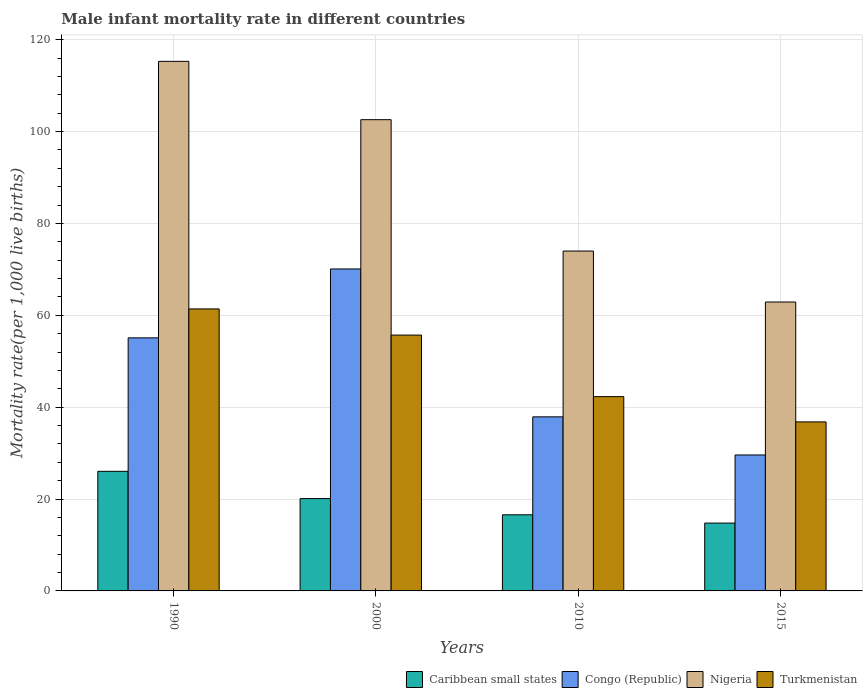Are the number of bars per tick equal to the number of legend labels?
Offer a terse response. Yes. Are the number of bars on each tick of the X-axis equal?
Offer a very short reply. Yes. How many bars are there on the 3rd tick from the left?
Provide a short and direct response. 4. What is the male infant mortality rate in Congo (Republic) in 2010?
Ensure brevity in your answer.  37.9. Across all years, what is the maximum male infant mortality rate in Nigeria?
Offer a terse response. 115.3. Across all years, what is the minimum male infant mortality rate in Turkmenistan?
Your answer should be compact. 36.8. In which year was the male infant mortality rate in Congo (Republic) minimum?
Your answer should be very brief. 2015. What is the total male infant mortality rate in Nigeria in the graph?
Offer a very short reply. 354.8. What is the difference between the male infant mortality rate in Turkmenistan in 2000 and that in 2015?
Your response must be concise. 18.9. What is the difference between the male infant mortality rate in Nigeria in 2000 and the male infant mortality rate in Turkmenistan in 2015?
Give a very brief answer. 65.8. What is the average male infant mortality rate in Congo (Republic) per year?
Your answer should be compact. 48.17. In the year 2010, what is the difference between the male infant mortality rate in Nigeria and male infant mortality rate in Turkmenistan?
Ensure brevity in your answer.  31.7. What is the ratio of the male infant mortality rate in Caribbean small states in 2000 to that in 2010?
Make the answer very short. 1.21. Is the male infant mortality rate in Congo (Republic) in 2000 less than that in 2015?
Provide a succinct answer. No. Is the difference between the male infant mortality rate in Nigeria in 1990 and 2010 greater than the difference between the male infant mortality rate in Turkmenistan in 1990 and 2010?
Your answer should be compact. Yes. What is the difference between the highest and the second highest male infant mortality rate in Nigeria?
Ensure brevity in your answer.  12.7. What is the difference between the highest and the lowest male infant mortality rate in Nigeria?
Your response must be concise. 52.4. In how many years, is the male infant mortality rate in Turkmenistan greater than the average male infant mortality rate in Turkmenistan taken over all years?
Offer a very short reply. 2. Is it the case that in every year, the sum of the male infant mortality rate in Caribbean small states and male infant mortality rate in Congo (Republic) is greater than the sum of male infant mortality rate in Turkmenistan and male infant mortality rate in Nigeria?
Provide a succinct answer. No. What does the 4th bar from the left in 2010 represents?
Offer a terse response. Turkmenistan. What does the 4th bar from the right in 1990 represents?
Offer a terse response. Caribbean small states. Is it the case that in every year, the sum of the male infant mortality rate in Congo (Republic) and male infant mortality rate in Caribbean small states is greater than the male infant mortality rate in Turkmenistan?
Offer a terse response. Yes. What is the difference between two consecutive major ticks on the Y-axis?
Make the answer very short. 20. Does the graph contain any zero values?
Provide a short and direct response. No. How many legend labels are there?
Give a very brief answer. 4. What is the title of the graph?
Offer a very short reply. Male infant mortality rate in different countries. What is the label or title of the Y-axis?
Offer a terse response. Mortality rate(per 1,0 live births). What is the Mortality rate(per 1,000 live births) of Caribbean small states in 1990?
Offer a very short reply. 26.04. What is the Mortality rate(per 1,000 live births) of Congo (Republic) in 1990?
Provide a succinct answer. 55.1. What is the Mortality rate(per 1,000 live births) of Nigeria in 1990?
Provide a short and direct response. 115.3. What is the Mortality rate(per 1,000 live births) of Turkmenistan in 1990?
Make the answer very short. 61.4. What is the Mortality rate(per 1,000 live births) in Caribbean small states in 2000?
Ensure brevity in your answer.  20.1. What is the Mortality rate(per 1,000 live births) in Congo (Republic) in 2000?
Offer a very short reply. 70.1. What is the Mortality rate(per 1,000 live births) of Nigeria in 2000?
Offer a very short reply. 102.6. What is the Mortality rate(per 1,000 live births) in Turkmenistan in 2000?
Offer a very short reply. 55.7. What is the Mortality rate(per 1,000 live births) of Caribbean small states in 2010?
Offer a very short reply. 16.57. What is the Mortality rate(per 1,000 live births) in Congo (Republic) in 2010?
Provide a short and direct response. 37.9. What is the Mortality rate(per 1,000 live births) in Turkmenistan in 2010?
Your answer should be compact. 42.3. What is the Mortality rate(per 1,000 live births) in Caribbean small states in 2015?
Your answer should be very brief. 14.77. What is the Mortality rate(per 1,000 live births) in Congo (Republic) in 2015?
Ensure brevity in your answer.  29.6. What is the Mortality rate(per 1,000 live births) in Nigeria in 2015?
Provide a succinct answer. 62.9. What is the Mortality rate(per 1,000 live births) in Turkmenistan in 2015?
Provide a succinct answer. 36.8. Across all years, what is the maximum Mortality rate(per 1,000 live births) of Caribbean small states?
Offer a very short reply. 26.04. Across all years, what is the maximum Mortality rate(per 1,000 live births) of Congo (Republic)?
Your answer should be compact. 70.1. Across all years, what is the maximum Mortality rate(per 1,000 live births) in Nigeria?
Offer a very short reply. 115.3. Across all years, what is the maximum Mortality rate(per 1,000 live births) of Turkmenistan?
Your answer should be very brief. 61.4. Across all years, what is the minimum Mortality rate(per 1,000 live births) in Caribbean small states?
Offer a very short reply. 14.77. Across all years, what is the minimum Mortality rate(per 1,000 live births) of Congo (Republic)?
Your response must be concise. 29.6. Across all years, what is the minimum Mortality rate(per 1,000 live births) in Nigeria?
Your answer should be compact. 62.9. Across all years, what is the minimum Mortality rate(per 1,000 live births) in Turkmenistan?
Provide a succinct answer. 36.8. What is the total Mortality rate(per 1,000 live births) in Caribbean small states in the graph?
Your answer should be very brief. 77.48. What is the total Mortality rate(per 1,000 live births) in Congo (Republic) in the graph?
Your response must be concise. 192.7. What is the total Mortality rate(per 1,000 live births) of Nigeria in the graph?
Make the answer very short. 354.8. What is the total Mortality rate(per 1,000 live births) of Turkmenistan in the graph?
Offer a very short reply. 196.2. What is the difference between the Mortality rate(per 1,000 live births) of Caribbean small states in 1990 and that in 2000?
Ensure brevity in your answer.  5.94. What is the difference between the Mortality rate(per 1,000 live births) of Congo (Republic) in 1990 and that in 2000?
Offer a terse response. -15. What is the difference between the Mortality rate(per 1,000 live births) of Nigeria in 1990 and that in 2000?
Your response must be concise. 12.7. What is the difference between the Mortality rate(per 1,000 live births) of Caribbean small states in 1990 and that in 2010?
Ensure brevity in your answer.  9.47. What is the difference between the Mortality rate(per 1,000 live births) in Nigeria in 1990 and that in 2010?
Ensure brevity in your answer.  41.3. What is the difference between the Mortality rate(per 1,000 live births) in Turkmenistan in 1990 and that in 2010?
Offer a very short reply. 19.1. What is the difference between the Mortality rate(per 1,000 live births) of Caribbean small states in 1990 and that in 2015?
Ensure brevity in your answer.  11.27. What is the difference between the Mortality rate(per 1,000 live births) of Nigeria in 1990 and that in 2015?
Provide a succinct answer. 52.4. What is the difference between the Mortality rate(per 1,000 live births) in Turkmenistan in 1990 and that in 2015?
Make the answer very short. 24.6. What is the difference between the Mortality rate(per 1,000 live births) in Caribbean small states in 2000 and that in 2010?
Offer a very short reply. 3.53. What is the difference between the Mortality rate(per 1,000 live births) of Congo (Republic) in 2000 and that in 2010?
Your answer should be very brief. 32.2. What is the difference between the Mortality rate(per 1,000 live births) in Nigeria in 2000 and that in 2010?
Your answer should be compact. 28.6. What is the difference between the Mortality rate(per 1,000 live births) of Caribbean small states in 2000 and that in 2015?
Keep it short and to the point. 5.33. What is the difference between the Mortality rate(per 1,000 live births) of Congo (Republic) in 2000 and that in 2015?
Your answer should be compact. 40.5. What is the difference between the Mortality rate(per 1,000 live births) of Nigeria in 2000 and that in 2015?
Your response must be concise. 39.7. What is the difference between the Mortality rate(per 1,000 live births) in Turkmenistan in 2000 and that in 2015?
Your response must be concise. 18.9. What is the difference between the Mortality rate(per 1,000 live births) in Caribbean small states in 2010 and that in 2015?
Offer a terse response. 1.8. What is the difference between the Mortality rate(per 1,000 live births) of Congo (Republic) in 2010 and that in 2015?
Give a very brief answer. 8.3. What is the difference between the Mortality rate(per 1,000 live births) in Nigeria in 2010 and that in 2015?
Provide a succinct answer. 11.1. What is the difference between the Mortality rate(per 1,000 live births) in Caribbean small states in 1990 and the Mortality rate(per 1,000 live births) in Congo (Republic) in 2000?
Offer a very short reply. -44.06. What is the difference between the Mortality rate(per 1,000 live births) in Caribbean small states in 1990 and the Mortality rate(per 1,000 live births) in Nigeria in 2000?
Ensure brevity in your answer.  -76.56. What is the difference between the Mortality rate(per 1,000 live births) of Caribbean small states in 1990 and the Mortality rate(per 1,000 live births) of Turkmenistan in 2000?
Your answer should be very brief. -29.66. What is the difference between the Mortality rate(per 1,000 live births) of Congo (Republic) in 1990 and the Mortality rate(per 1,000 live births) of Nigeria in 2000?
Your response must be concise. -47.5. What is the difference between the Mortality rate(per 1,000 live births) in Congo (Republic) in 1990 and the Mortality rate(per 1,000 live births) in Turkmenistan in 2000?
Give a very brief answer. -0.6. What is the difference between the Mortality rate(per 1,000 live births) in Nigeria in 1990 and the Mortality rate(per 1,000 live births) in Turkmenistan in 2000?
Ensure brevity in your answer.  59.6. What is the difference between the Mortality rate(per 1,000 live births) in Caribbean small states in 1990 and the Mortality rate(per 1,000 live births) in Congo (Republic) in 2010?
Offer a terse response. -11.86. What is the difference between the Mortality rate(per 1,000 live births) of Caribbean small states in 1990 and the Mortality rate(per 1,000 live births) of Nigeria in 2010?
Your answer should be compact. -47.96. What is the difference between the Mortality rate(per 1,000 live births) of Caribbean small states in 1990 and the Mortality rate(per 1,000 live births) of Turkmenistan in 2010?
Provide a succinct answer. -16.26. What is the difference between the Mortality rate(per 1,000 live births) of Congo (Republic) in 1990 and the Mortality rate(per 1,000 live births) of Nigeria in 2010?
Your response must be concise. -18.9. What is the difference between the Mortality rate(per 1,000 live births) of Congo (Republic) in 1990 and the Mortality rate(per 1,000 live births) of Turkmenistan in 2010?
Keep it short and to the point. 12.8. What is the difference between the Mortality rate(per 1,000 live births) of Caribbean small states in 1990 and the Mortality rate(per 1,000 live births) of Congo (Republic) in 2015?
Make the answer very short. -3.56. What is the difference between the Mortality rate(per 1,000 live births) of Caribbean small states in 1990 and the Mortality rate(per 1,000 live births) of Nigeria in 2015?
Your answer should be compact. -36.86. What is the difference between the Mortality rate(per 1,000 live births) in Caribbean small states in 1990 and the Mortality rate(per 1,000 live births) in Turkmenistan in 2015?
Your answer should be compact. -10.76. What is the difference between the Mortality rate(per 1,000 live births) in Nigeria in 1990 and the Mortality rate(per 1,000 live births) in Turkmenistan in 2015?
Your response must be concise. 78.5. What is the difference between the Mortality rate(per 1,000 live births) in Caribbean small states in 2000 and the Mortality rate(per 1,000 live births) in Congo (Republic) in 2010?
Your answer should be compact. -17.8. What is the difference between the Mortality rate(per 1,000 live births) in Caribbean small states in 2000 and the Mortality rate(per 1,000 live births) in Nigeria in 2010?
Provide a succinct answer. -53.9. What is the difference between the Mortality rate(per 1,000 live births) of Caribbean small states in 2000 and the Mortality rate(per 1,000 live births) of Turkmenistan in 2010?
Your response must be concise. -22.2. What is the difference between the Mortality rate(per 1,000 live births) in Congo (Republic) in 2000 and the Mortality rate(per 1,000 live births) in Nigeria in 2010?
Offer a terse response. -3.9. What is the difference between the Mortality rate(per 1,000 live births) in Congo (Republic) in 2000 and the Mortality rate(per 1,000 live births) in Turkmenistan in 2010?
Give a very brief answer. 27.8. What is the difference between the Mortality rate(per 1,000 live births) of Nigeria in 2000 and the Mortality rate(per 1,000 live births) of Turkmenistan in 2010?
Keep it short and to the point. 60.3. What is the difference between the Mortality rate(per 1,000 live births) in Caribbean small states in 2000 and the Mortality rate(per 1,000 live births) in Congo (Republic) in 2015?
Keep it short and to the point. -9.5. What is the difference between the Mortality rate(per 1,000 live births) of Caribbean small states in 2000 and the Mortality rate(per 1,000 live births) of Nigeria in 2015?
Make the answer very short. -42.8. What is the difference between the Mortality rate(per 1,000 live births) of Caribbean small states in 2000 and the Mortality rate(per 1,000 live births) of Turkmenistan in 2015?
Offer a terse response. -16.7. What is the difference between the Mortality rate(per 1,000 live births) of Congo (Republic) in 2000 and the Mortality rate(per 1,000 live births) of Turkmenistan in 2015?
Offer a very short reply. 33.3. What is the difference between the Mortality rate(per 1,000 live births) in Nigeria in 2000 and the Mortality rate(per 1,000 live births) in Turkmenistan in 2015?
Your answer should be very brief. 65.8. What is the difference between the Mortality rate(per 1,000 live births) of Caribbean small states in 2010 and the Mortality rate(per 1,000 live births) of Congo (Republic) in 2015?
Your answer should be compact. -13.03. What is the difference between the Mortality rate(per 1,000 live births) of Caribbean small states in 2010 and the Mortality rate(per 1,000 live births) of Nigeria in 2015?
Provide a succinct answer. -46.33. What is the difference between the Mortality rate(per 1,000 live births) of Caribbean small states in 2010 and the Mortality rate(per 1,000 live births) of Turkmenistan in 2015?
Keep it short and to the point. -20.23. What is the difference between the Mortality rate(per 1,000 live births) of Congo (Republic) in 2010 and the Mortality rate(per 1,000 live births) of Nigeria in 2015?
Your response must be concise. -25. What is the difference between the Mortality rate(per 1,000 live births) of Congo (Republic) in 2010 and the Mortality rate(per 1,000 live births) of Turkmenistan in 2015?
Make the answer very short. 1.1. What is the difference between the Mortality rate(per 1,000 live births) of Nigeria in 2010 and the Mortality rate(per 1,000 live births) of Turkmenistan in 2015?
Your answer should be very brief. 37.2. What is the average Mortality rate(per 1,000 live births) of Caribbean small states per year?
Provide a short and direct response. 19.37. What is the average Mortality rate(per 1,000 live births) of Congo (Republic) per year?
Ensure brevity in your answer.  48.17. What is the average Mortality rate(per 1,000 live births) in Nigeria per year?
Your response must be concise. 88.7. What is the average Mortality rate(per 1,000 live births) of Turkmenistan per year?
Provide a short and direct response. 49.05. In the year 1990, what is the difference between the Mortality rate(per 1,000 live births) of Caribbean small states and Mortality rate(per 1,000 live births) of Congo (Republic)?
Give a very brief answer. -29.06. In the year 1990, what is the difference between the Mortality rate(per 1,000 live births) in Caribbean small states and Mortality rate(per 1,000 live births) in Nigeria?
Offer a very short reply. -89.26. In the year 1990, what is the difference between the Mortality rate(per 1,000 live births) in Caribbean small states and Mortality rate(per 1,000 live births) in Turkmenistan?
Provide a short and direct response. -35.36. In the year 1990, what is the difference between the Mortality rate(per 1,000 live births) of Congo (Republic) and Mortality rate(per 1,000 live births) of Nigeria?
Offer a very short reply. -60.2. In the year 1990, what is the difference between the Mortality rate(per 1,000 live births) of Congo (Republic) and Mortality rate(per 1,000 live births) of Turkmenistan?
Your answer should be compact. -6.3. In the year 1990, what is the difference between the Mortality rate(per 1,000 live births) in Nigeria and Mortality rate(per 1,000 live births) in Turkmenistan?
Offer a terse response. 53.9. In the year 2000, what is the difference between the Mortality rate(per 1,000 live births) in Caribbean small states and Mortality rate(per 1,000 live births) in Congo (Republic)?
Give a very brief answer. -50. In the year 2000, what is the difference between the Mortality rate(per 1,000 live births) in Caribbean small states and Mortality rate(per 1,000 live births) in Nigeria?
Provide a short and direct response. -82.5. In the year 2000, what is the difference between the Mortality rate(per 1,000 live births) in Caribbean small states and Mortality rate(per 1,000 live births) in Turkmenistan?
Make the answer very short. -35.6. In the year 2000, what is the difference between the Mortality rate(per 1,000 live births) of Congo (Republic) and Mortality rate(per 1,000 live births) of Nigeria?
Make the answer very short. -32.5. In the year 2000, what is the difference between the Mortality rate(per 1,000 live births) of Congo (Republic) and Mortality rate(per 1,000 live births) of Turkmenistan?
Offer a very short reply. 14.4. In the year 2000, what is the difference between the Mortality rate(per 1,000 live births) in Nigeria and Mortality rate(per 1,000 live births) in Turkmenistan?
Your response must be concise. 46.9. In the year 2010, what is the difference between the Mortality rate(per 1,000 live births) in Caribbean small states and Mortality rate(per 1,000 live births) in Congo (Republic)?
Your answer should be compact. -21.33. In the year 2010, what is the difference between the Mortality rate(per 1,000 live births) in Caribbean small states and Mortality rate(per 1,000 live births) in Nigeria?
Your answer should be very brief. -57.43. In the year 2010, what is the difference between the Mortality rate(per 1,000 live births) of Caribbean small states and Mortality rate(per 1,000 live births) of Turkmenistan?
Make the answer very short. -25.73. In the year 2010, what is the difference between the Mortality rate(per 1,000 live births) in Congo (Republic) and Mortality rate(per 1,000 live births) in Nigeria?
Your response must be concise. -36.1. In the year 2010, what is the difference between the Mortality rate(per 1,000 live births) of Nigeria and Mortality rate(per 1,000 live births) of Turkmenistan?
Make the answer very short. 31.7. In the year 2015, what is the difference between the Mortality rate(per 1,000 live births) in Caribbean small states and Mortality rate(per 1,000 live births) in Congo (Republic)?
Provide a short and direct response. -14.83. In the year 2015, what is the difference between the Mortality rate(per 1,000 live births) in Caribbean small states and Mortality rate(per 1,000 live births) in Nigeria?
Provide a short and direct response. -48.13. In the year 2015, what is the difference between the Mortality rate(per 1,000 live births) of Caribbean small states and Mortality rate(per 1,000 live births) of Turkmenistan?
Provide a short and direct response. -22.03. In the year 2015, what is the difference between the Mortality rate(per 1,000 live births) of Congo (Republic) and Mortality rate(per 1,000 live births) of Nigeria?
Provide a succinct answer. -33.3. In the year 2015, what is the difference between the Mortality rate(per 1,000 live births) of Nigeria and Mortality rate(per 1,000 live births) of Turkmenistan?
Offer a terse response. 26.1. What is the ratio of the Mortality rate(per 1,000 live births) of Caribbean small states in 1990 to that in 2000?
Your answer should be compact. 1.3. What is the ratio of the Mortality rate(per 1,000 live births) of Congo (Republic) in 1990 to that in 2000?
Make the answer very short. 0.79. What is the ratio of the Mortality rate(per 1,000 live births) of Nigeria in 1990 to that in 2000?
Your answer should be compact. 1.12. What is the ratio of the Mortality rate(per 1,000 live births) of Turkmenistan in 1990 to that in 2000?
Your response must be concise. 1.1. What is the ratio of the Mortality rate(per 1,000 live births) in Caribbean small states in 1990 to that in 2010?
Provide a succinct answer. 1.57. What is the ratio of the Mortality rate(per 1,000 live births) of Congo (Republic) in 1990 to that in 2010?
Provide a short and direct response. 1.45. What is the ratio of the Mortality rate(per 1,000 live births) of Nigeria in 1990 to that in 2010?
Give a very brief answer. 1.56. What is the ratio of the Mortality rate(per 1,000 live births) in Turkmenistan in 1990 to that in 2010?
Make the answer very short. 1.45. What is the ratio of the Mortality rate(per 1,000 live births) in Caribbean small states in 1990 to that in 2015?
Keep it short and to the point. 1.76. What is the ratio of the Mortality rate(per 1,000 live births) in Congo (Republic) in 1990 to that in 2015?
Provide a short and direct response. 1.86. What is the ratio of the Mortality rate(per 1,000 live births) in Nigeria in 1990 to that in 2015?
Keep it short and to the point. 1.83. What is the ratio of the Mortality rate(per 1,000 live births) in Turkmenistan in 1990 to that in 2015?
Provide a short and direct response. 1.67. What is the ratio of the Mortality rate(per 1,000 live births) of Caribbean small states in 2000 to that in 2010?
Your answer should be compact. 1.21. What is the ratio of the Mortality rate(per 1,000 live births) of Congo (Republic) in 2000 to that in 2010?
Your answer should be compact. 1.85. What is the ratio of the Mortality rate(per 1,000 live births) in Nigeria in 2000 to that in 2010?
Offer a very short reply. 1.39. What is the ratio of the Mortality rate(per 1,000 live births) of Turkmenistan in 2000 to that in 2010?
Provide a succinct answer. 1.32. What is the ratio of the Mortality rate(per 1,000 live births) in Caribbean small states in 2000 to that in 2015?
Provide a short and direct response. 1.36. What is the ratio of the Mortality rate(per 1,000 live births) of Congo (Republic) in 2000 to that in 2015?
Your answer should be very brief. 2.37. What is the ratio of the Mortality rate(per 1,000 live births) of Nigeria in 2000 to that in 2015?
Your answer should be very brief. 1.63. What is the ratio of the Mortality rate(per 1,000 live births) in Turkmenistan in 2000 to that in 2015?
Provide a succinct answer. 1.51. What is the ratio of the Mortality rate(per 1,000 live births) of Caribbean small states in 2010 to that in 2015?
Your answer should be very brief. 1.12. What is the ratio of the Mortality rate(per 1,000 live births) of Congo (Republic) in 2010 to that in 2015?
Offer a very short reply. 1.28. What is the ratio of the Mortality rate(per 1,000 live births) of Nigeria in 2010 to that in 2015?
Your response must be concise. 1.18. What is the ratio of the Mortality rate(per 1,000 live births) of Turkmenistan in 2010 to that in 2015?
Your answer should be compact. 1.15. What is the difference between the highest and the second highest Mortality rate(per 1,000 live births) in Caribbean small states?
Your response must be concise. 5.94. What is the difference between the highest and the second highest Mortality rate(per 1,000 live births) of Nigeria?
Keep it short and to the point. 12.7. What is the difference between the highest and the lowest Mortality rate(per 1,000 live births) in Caribbean small states?
Give a very brief answer. 11.27. What is the difference between the highest and the lowest Mortality rate(per 1,000 live births) of Congo (Republic)?
Your answer should be very brief. 40.5. What is the difference between the highest and the lowest Mortality rate(per 1,000 live births) of Nigeria?
Keep it short and to the point. 52.4. What is the difference between the highest and the lowest Mortality rate(per 1,000 live births) of Turkmenistan?
Give a very brief answer. 24.6. 